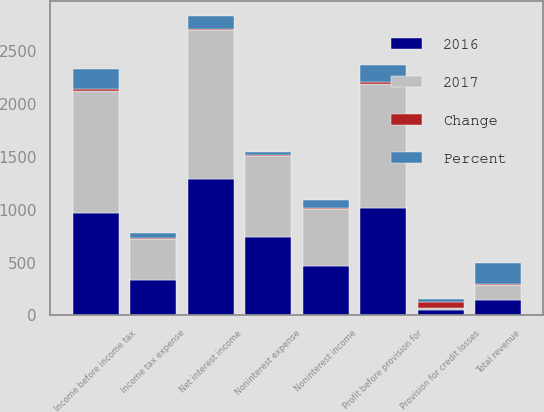<chart> <loc_0><loc_0><loc_500><loc_500><stacked_bar_chart><ecel><fcel>Net interest income<fcel>Noninterest income<fcel>Total revenue<fcel>Noninterest expense<fcel>Profit before provision for<fcel>Provision for credit losses<fcel>Income before income tax<fcel>Income tax expense<nl><fcel>2017<fcel>1411<fcel>538<fcel>143.5<fcel>772<fcel>1177<fcel>19<fcel>1158<fcel>384<nl><fcel>2016<fcel>1288<fcel>466<fcel>143.5<fcel>741<fcel>1013<fcel>47<fcel>966<fcel>335<nl><fcel>Percent<fcel>123<fcel>72<fcel>195<fcel>31<fcel>164<fcel>28<fcel>192<fcel>49<nl><fcel>Change<fcel>10<fcel>15<fcel>11<fcel>4<fcel>16<fcel>60<fcel>20<fcel>15<nl></chart> 